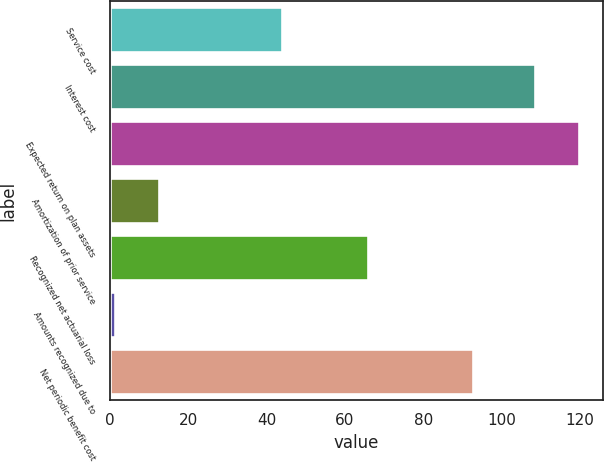<chart> <loc_0><loc_0><loc_500><loc_500><bar_chart><fcel>Service cost<fcel>Interest cost<fcel>Expected return on plan assets<fcel>Amortization of prior service<fcel>Recognized net actuarial loss<fcel>Amounts recognized due to<fcel>Net periodic benefit cost<nl><fcel>44<fcel>108.5<fcel>119.8<fcel>12.7<fcel>65.8<fcel>1.4<fcel>92.8<nl></chart> 